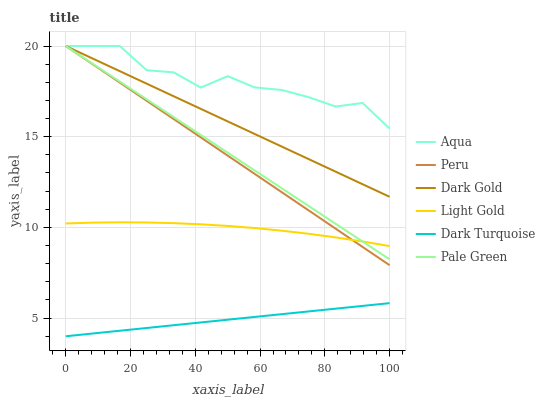Does Dark Turquoise have the minimum area under the curve?
Answer yes or no. Yes. Does Aqua have the maximum area under the curve?
Answer yes or no. Yes. Does Aqua have the minimum area under the curve?
Answer yes or no. No. Does Dark Turquoise have the maximum area under the curve?
Answer yes or no. No. Is Dark Turquoise the smoothest?
Answer yes or no. Yes. Is Aqua the roughest?
Answer yes or no. Yes. Is Aqua the smoothest?
Answer yes or no. No. Is Dark Turquoise the roughest?
Answer yes or no. No. Does Dark Turquoise have the lowest value?
Answer yes or no. Yes. Does Aqua have the lowest value?
Answer yes or no. No. Does Peru have the highest value?
Answer yes or no. Yes. Does Dark Turquoise have the highest value?
Answer yes or no. No. Is Dark Turquoise less than Peru?
Answer yes or no. Yes. Is Light Gold greater than Dark Turquoise?
Answer yes or no. Yes. Does Light Gold intersect Peru?
Answer yes or no. Yes. Is Light Gold less than Peru?
Answer yes or no. No. Is Light Gold greater than Peru?
Answer yes or no. No. Does Dark Turquoise intersect Peru?
Answer yes or no. No. 